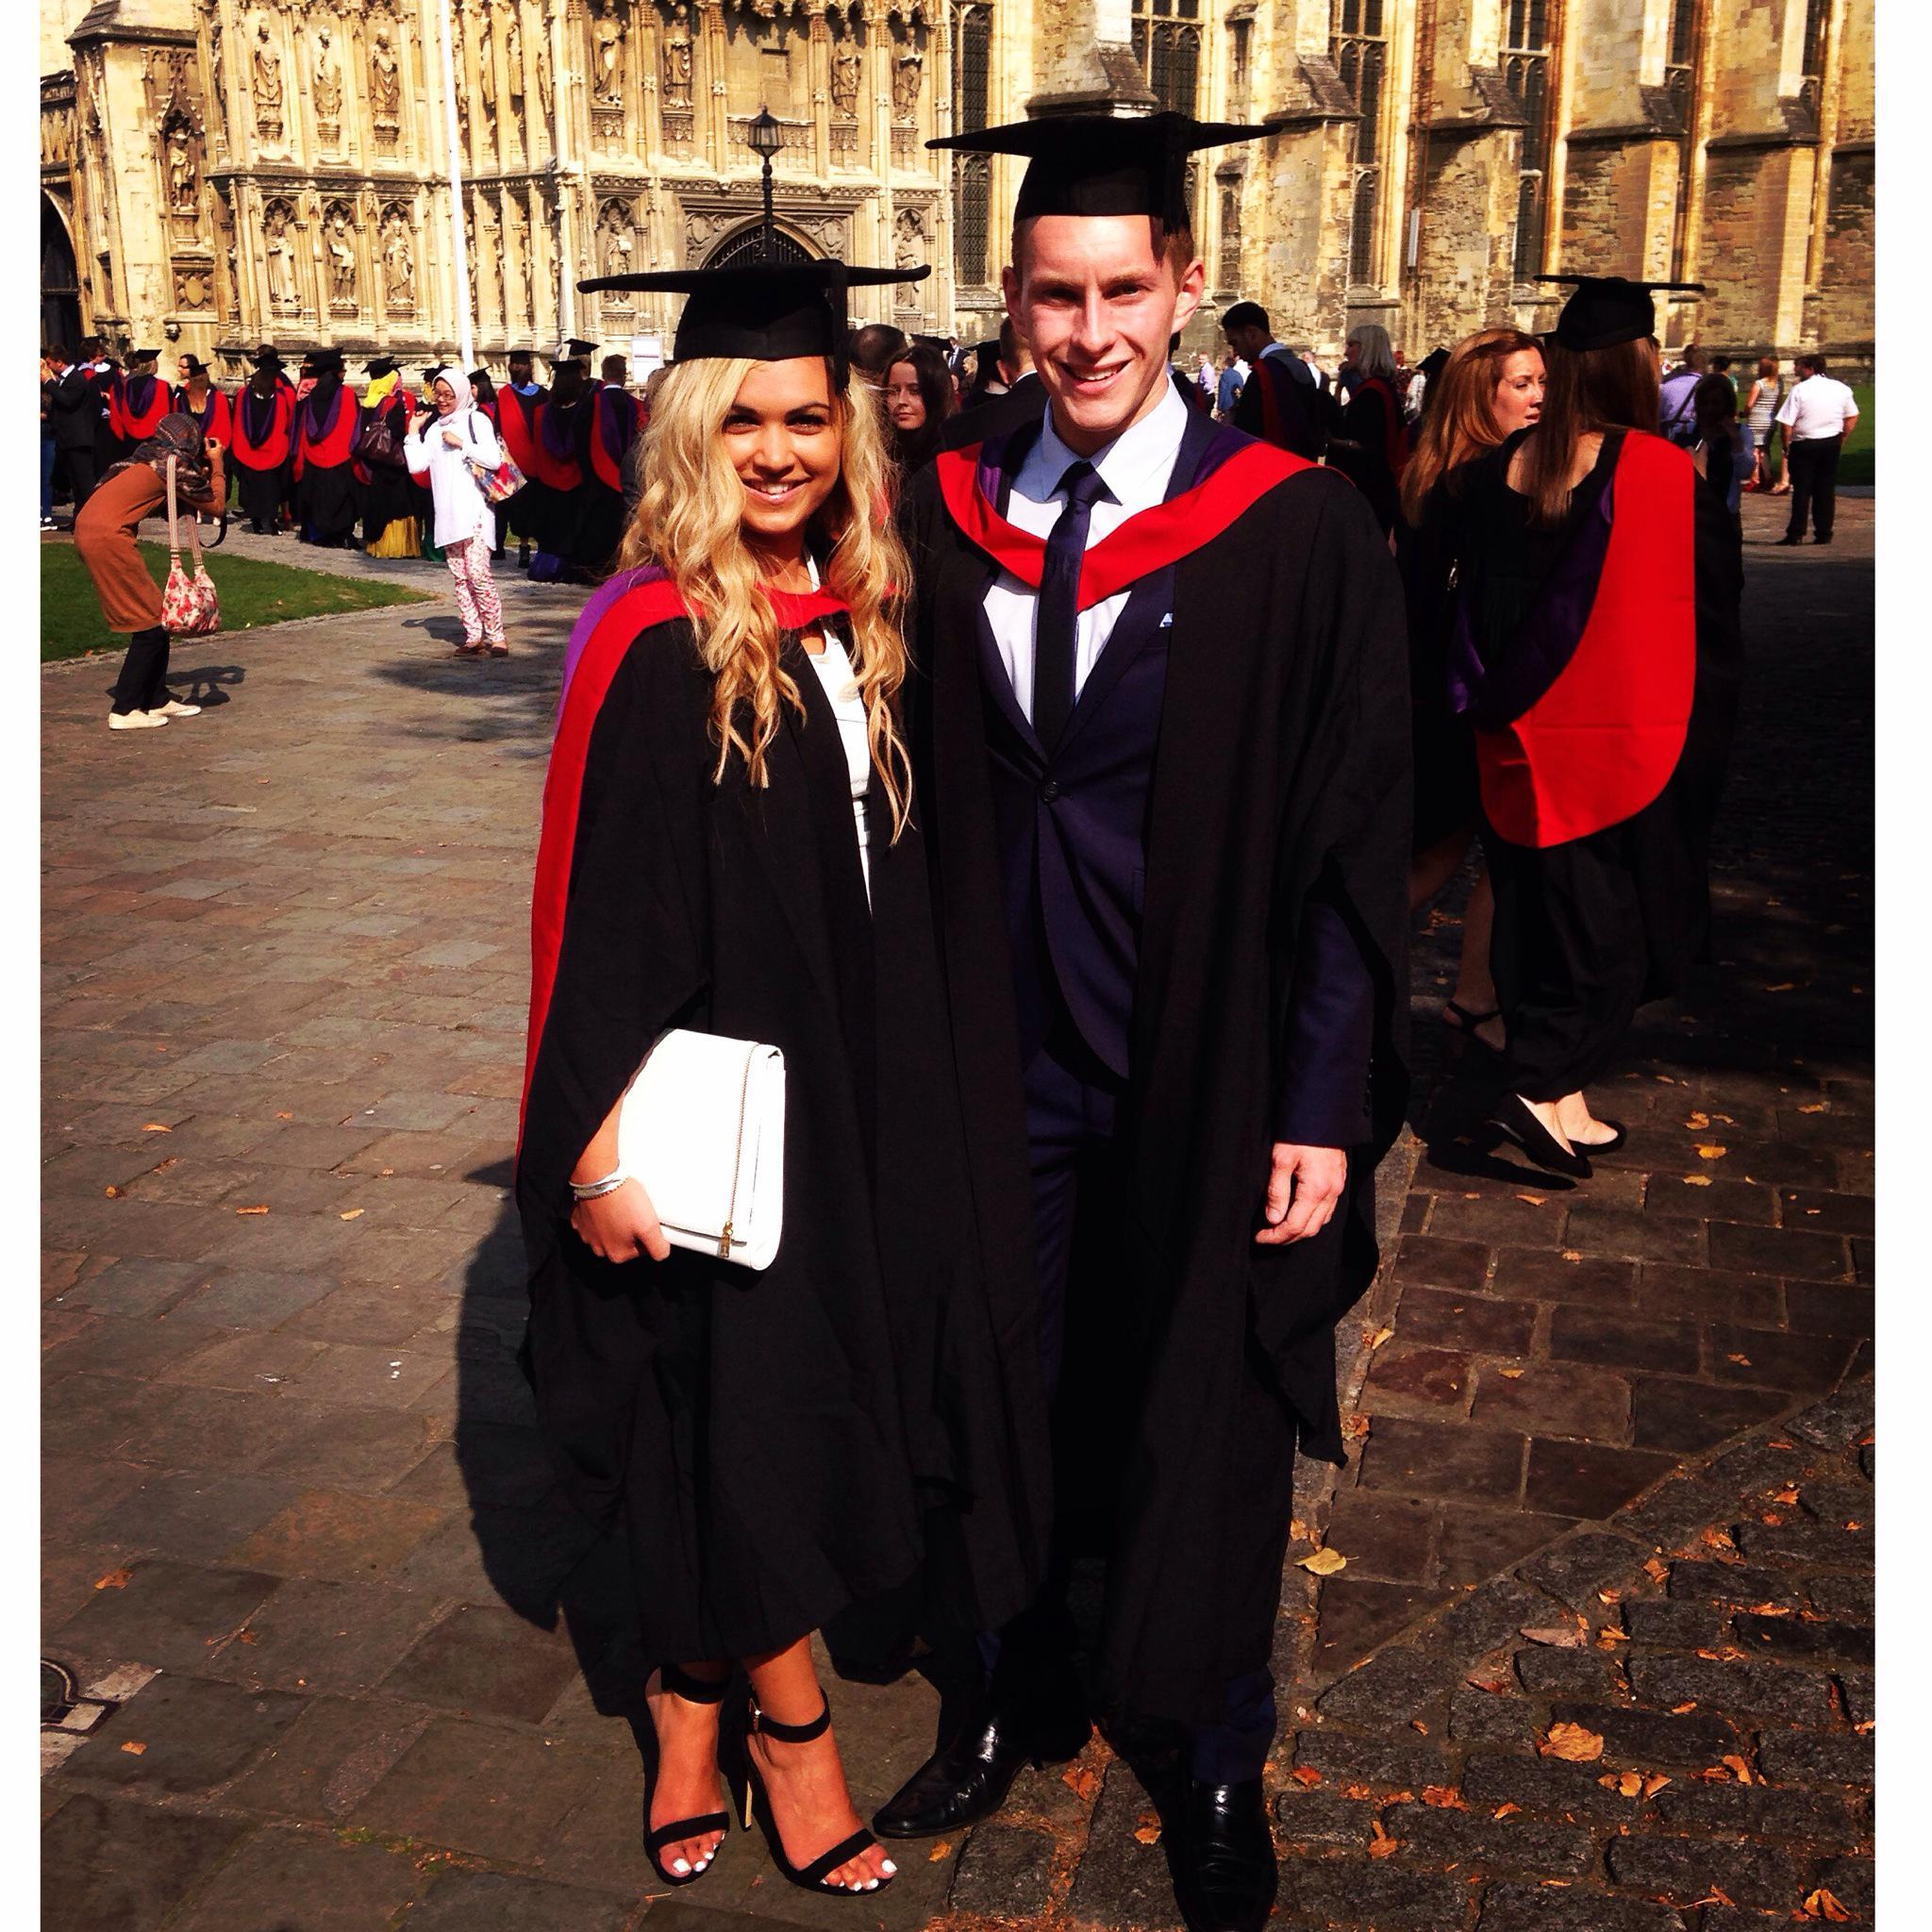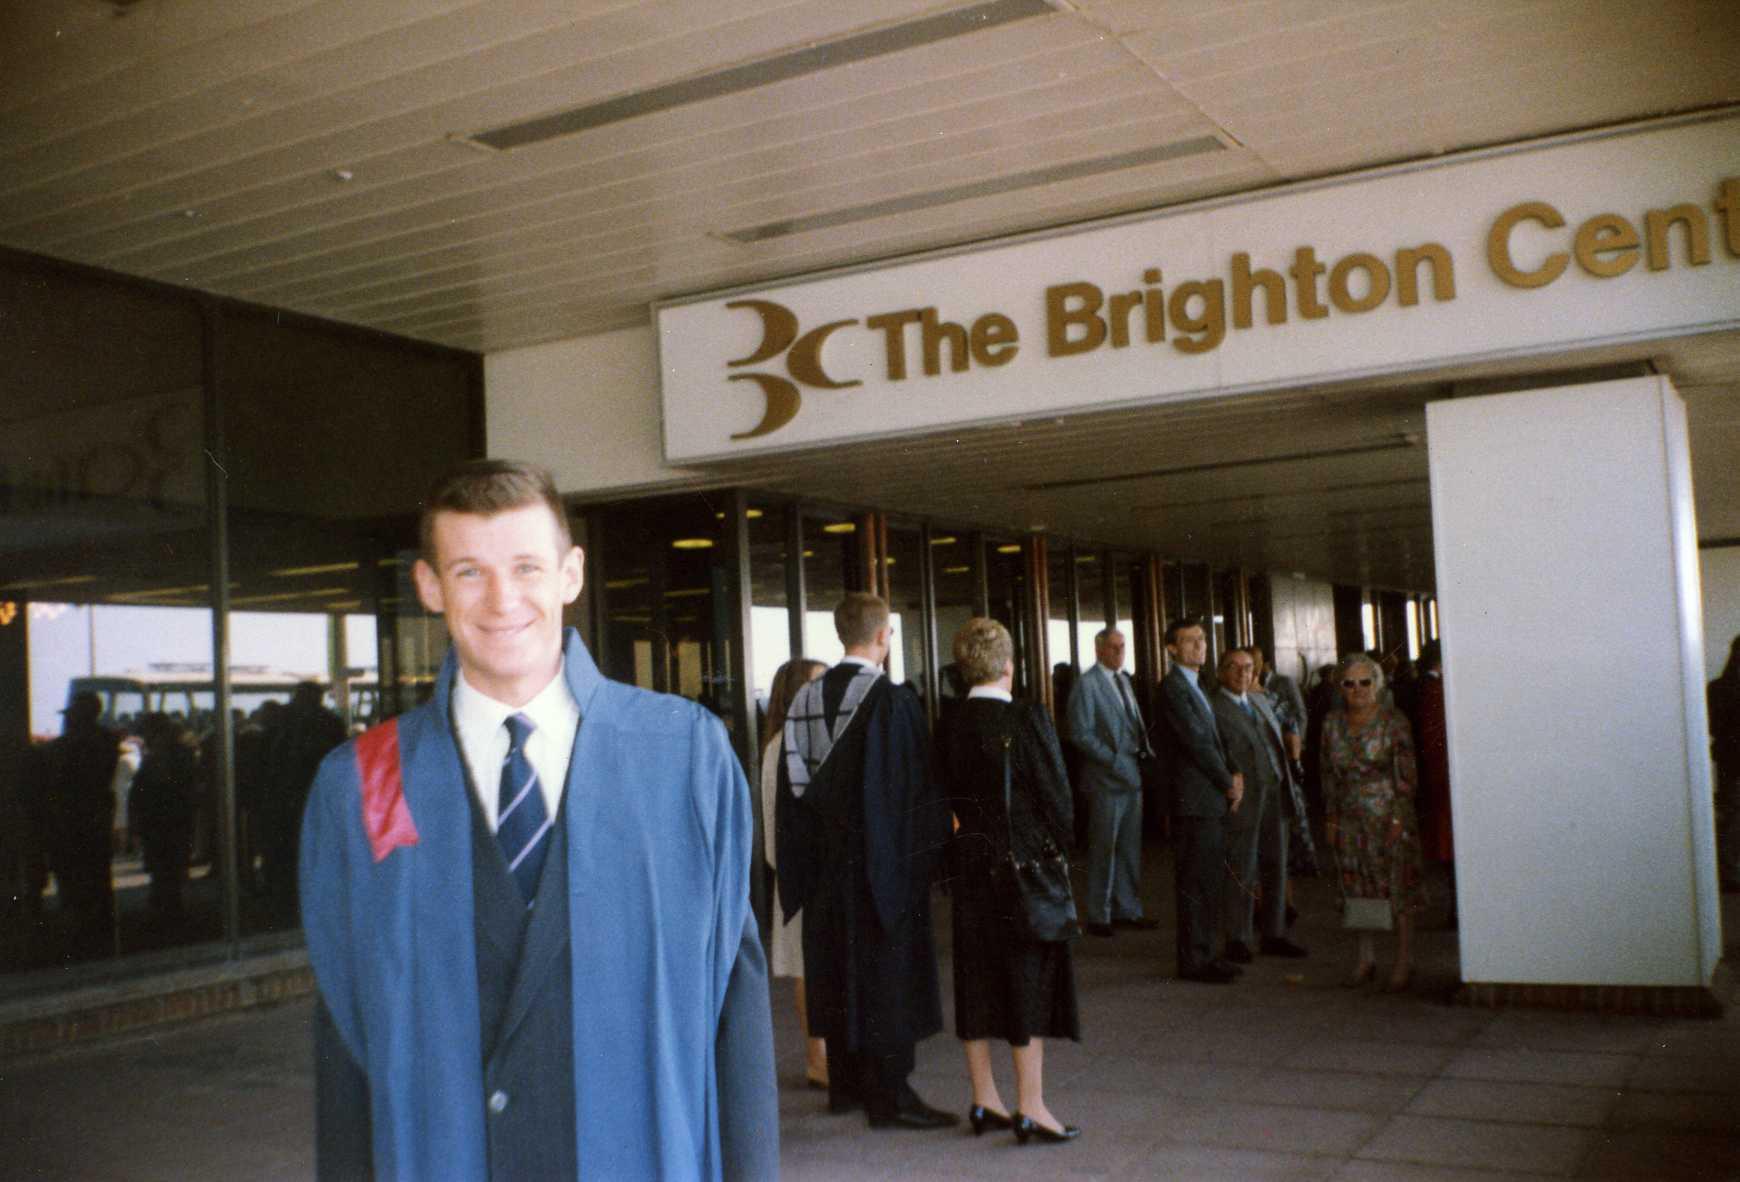The first image is the image on the left, the second image is the image on the right. Given the left and right images, does the statement "A single graduate is posing wearing a blue outfit in the image on the right." hold true? Answer yes or no. Yes. The first image is the image on the left, the second image is the image on the right. Given the left and right images, does the statement "Two college graduates wearing black gowns and mortarboards are the focus of one image, while a single male wearing a gown is the focus of the second image." hold true? Answer yes or no. Yes. 